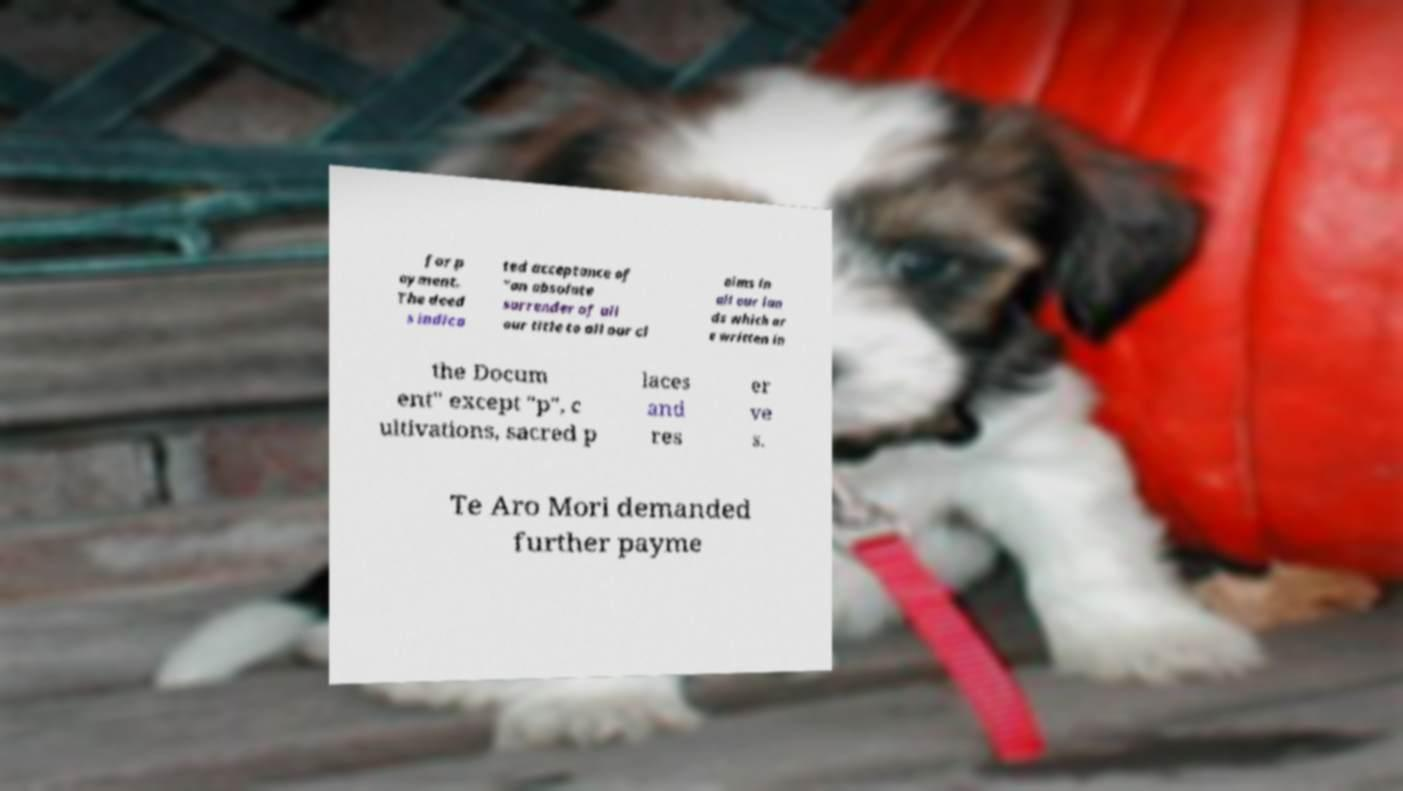I need the written content from this picture converted into text. Can you do that? for p ayment. The deed s indica ted acceptance of "an absolute surrender of all our title to all our cl aims in all our lan ds which ar e written in the Docum ent" except "p", c ultivations, sacred p laces and res er ve s. Te Aro Mori demanded further payme 